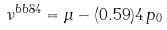Convert formula to latex. <formula><loc_0><loc_0><loc_500><loc_500>\nu ^ { b b 8 4 } = \mu - ( 0 . 5 9 ) 4 \, p _ { 0 }</formula> 